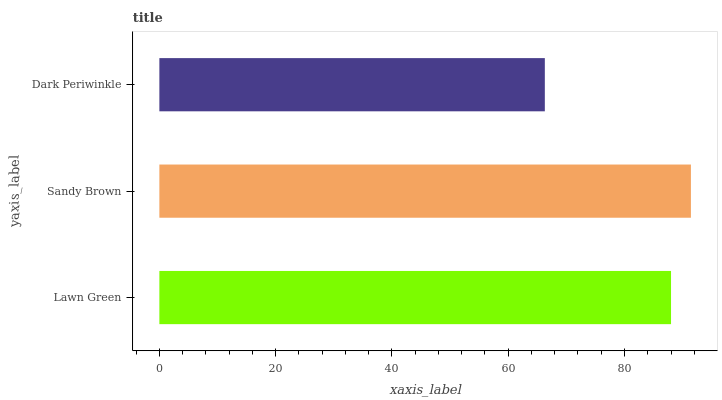Is Dark Periwinkle the minimum?
Answer yes or no. Yes. Is Sandy Brown the maximum?
Answer yes or no. Yes. Is Sandy Brown the minimum?
Answer yes or no. No. Is Dark Periwinkle the maximum?
Answer yes or no. No. Is Sandy Brown greater than Dark Periwinkle?
Answer yes or no. Yes. Is Dark Periwinkle less than Sandy Brown?
Answer yes or no. Yes. Is Dark Periwinkle greater than Sandy Brown?
Answer yes or no. No. Is Sandy Brown less than Dark Periwinkle?
Answer yes or no. No. Is Lawn Green the high median?
Answer yes or no. Yes. Is Lawn Green the low median?
Answer yes or no. Yes. Is Dark Periwinkle the high median?
Answer yes or no. No. Is Sandy Brown the low median?
Answer yes or no. No. 